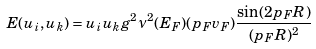<formula> <loc_0><loc_0><loc_500><loc_500>E ( u _ { i } , u _ { k } ) = u _ { i } u _ { k } g ^ { 2 } \nu ^ { 2 } ( E _ { F } ) ( p _ { F } v _ { F } ) \frac { \sin ( 2 p _ { F } R ) } { ( p _ { F } R ) ^ { 2 } } \,</formula> 